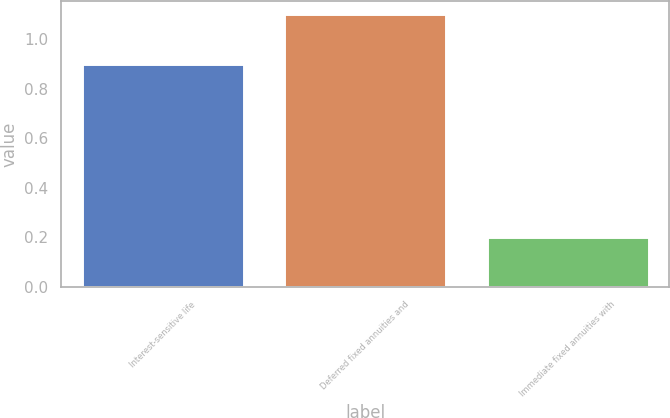Convert chart. <chart><loc_0><loc_0><loc_500><loc_500><bar_chart><fcel>Interest-sensitive life<fcel>Deferred fixed annuities and<fcel>Immediate fixed annuities with<nl><fcel>0.9<fcel>1.1<fcel>0.2<nl></chart> 